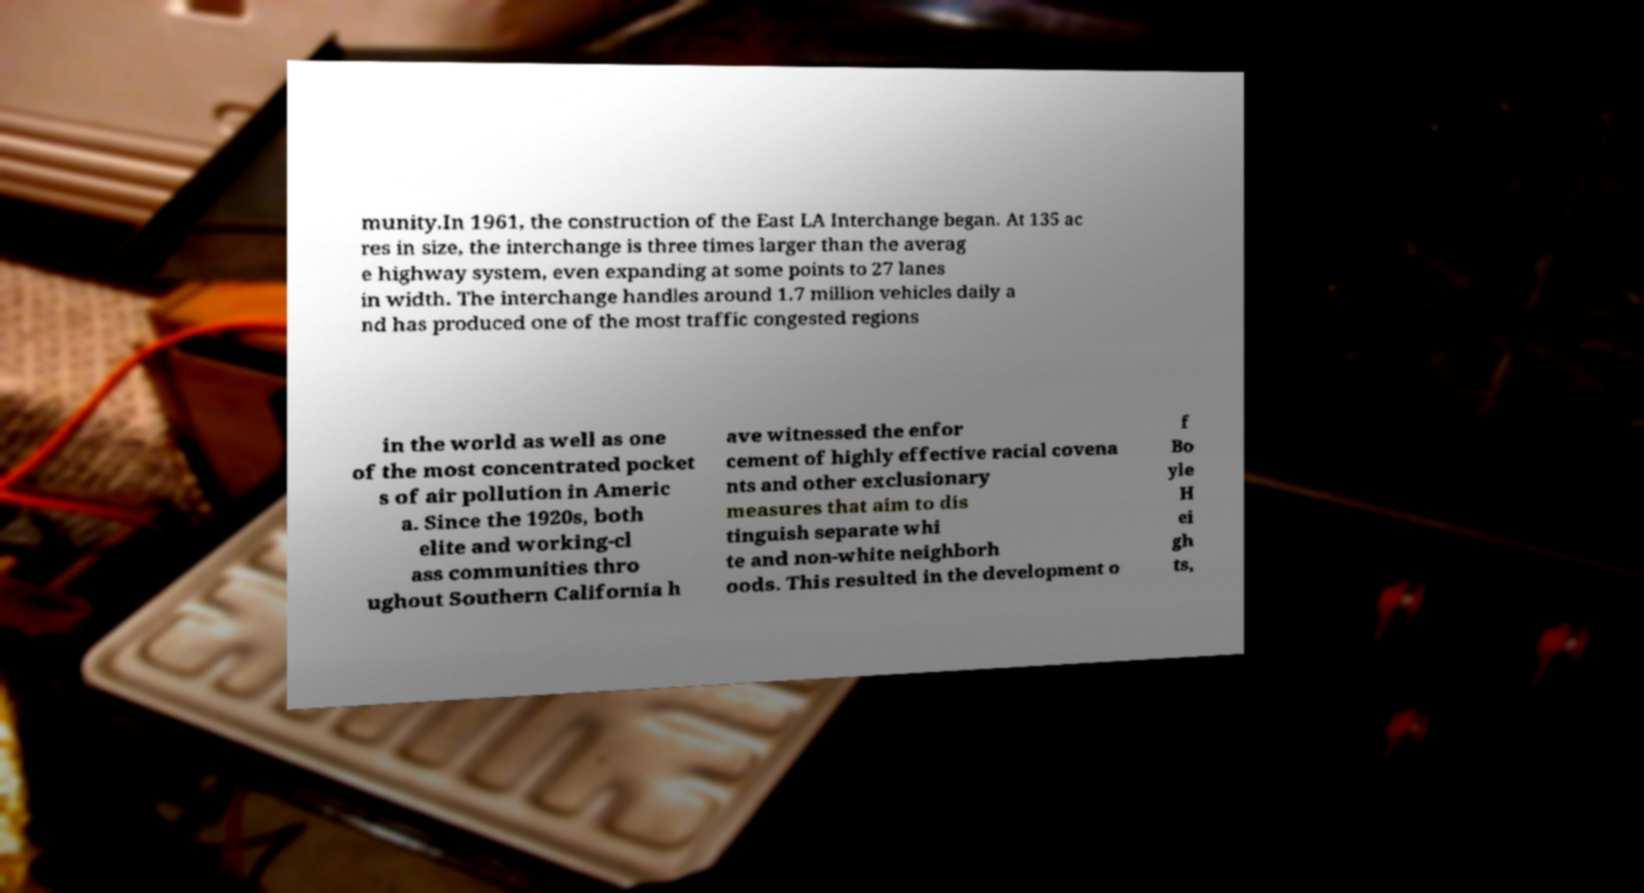Could you assist in decoding the text presented in this image and type it out clearly? munity.In 1961, the construction of the East LA Interchange began. At 135 ac res in size, the interchange is three times larger than the averag e highway system, even expanding at some points to 27 lanes in width. The interchange handles around 1.7 million vehicles daily a nd has produced one of the most traffic congested regions in the world as well as one of the most concentrated pocket s of air pollution in Americ a. Since the 1920s, both elite and working-cl ass communities thro ughout Southern California h ave witnessed the enfor cement of highly effective racial covena nts and other exclusionary measures that aim to dis tinguish separate whi te and non-white neighborh oods. This resulted in the development o f Bo yle H ei gh ts, 